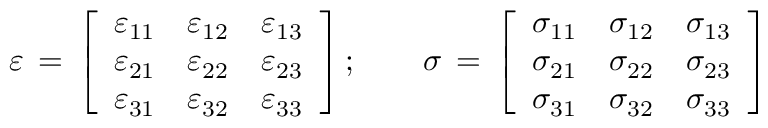Convert formula to latex. <formula><loc_0><loc_0><loc_500><loc_500>{ \varepsilon } \, = \, { \left [ \begin{array} { l l l } { \varepsilon _ { 1 1 } } & { \varepsilon _ { 1 2 } } & { \varepsilon _ { 1 3 } } \\ { \varepsilon _ { 2 1 } } & { \varepsilon _ { 2 2 } } & { \varepsilon _ { 2 3 } } \\ { \varepsilon _ { 3 1 } } & { \varepsilon _ { 3 2 } } & { \varepsilon _ { 3 3 } } \end{array} \right ] } \, ; \quad { \sigma } \, = \, { \left [ \begin{array} { l l l } { \sigma _ { 1 1 } } & { \sigma _ { 1 2 } } & { \sigma _ { 1 3 } } \\ { \sigma _ { 2 1 } } & { \sigma _ { 2 2 } } & { \sigma _ { 2 3 } } \\ { \sigma _ { 3 1 } } & { \sigma _ { 3 2 } } & { \sigma _ { 3 3 } } \end{array} \right ] }</formula> 